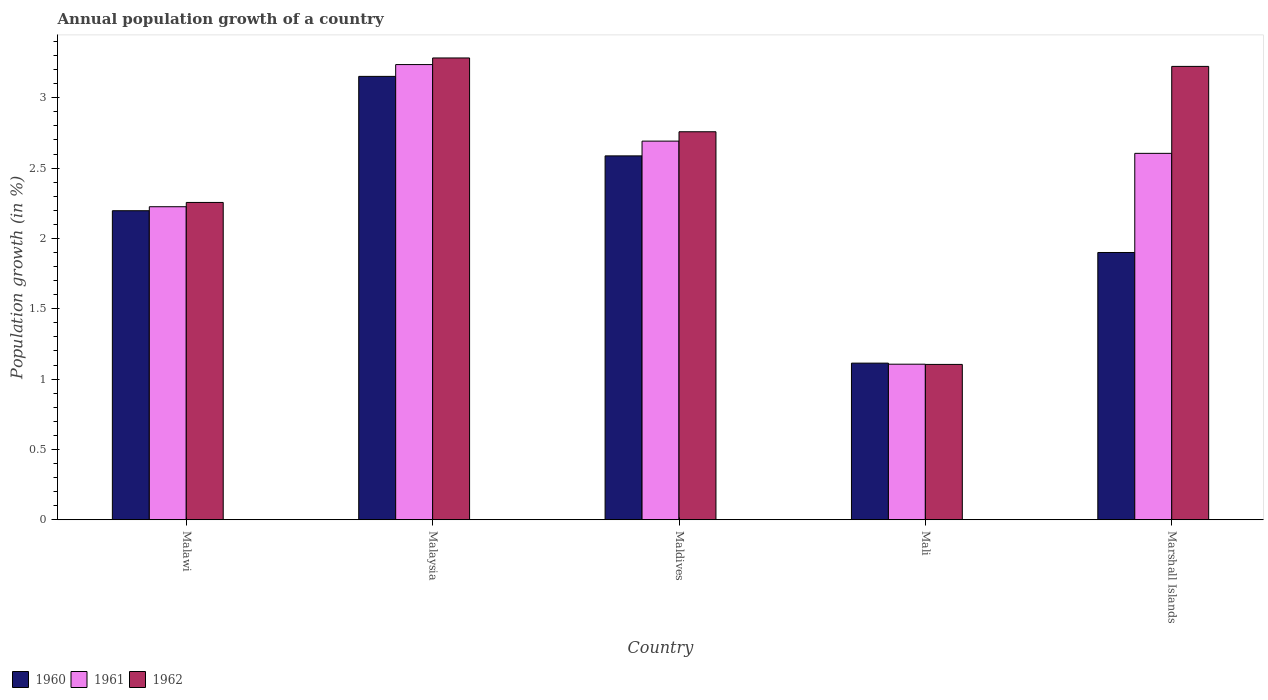How many different coloured bars are there?
Make the answer very short. 3. How many bars are there on the 4th tick from the left?
Make the answer very short. 3. How many bars are there on the 2nd tick from the right?
Offer a very short reply. 3. What is the label of the 1st group of bars from the left?
Your answer should be compact. Malawi. What is the annual population growth in 1961 in Mali?
Provide a short and direct response. 1.11. Across all countries, what is the maximum annual population growth in 1961?
Offer a very short reply. 3.24. Across all countries, what is the minimum annual population growth in 1962?
Provide a short and direct response. 1.1. In which country was the annual population growth in 1961 maximum?
Your answer should be very brief. Malaysia. In which country was the annual population growth in 1962 minimum?
Offer a very short reply. Mali. What is the total annual population growth in 1961 in the graph?
Offer a very short reply. 11.86. What is the difference between the annual population growth in 1960 in Malawi and that in Malaysia?
Your answer should be compact. -0.96. What is the difference between the annual population growth in 1960 in Malaysia and the annual population growth in 1961 in Marshall Islands?
Offer a terse response. 0.55. What is the average annual population growth in 1960 per country?
Offer a terse response. 2.19. What is the difference between the annual population growth of/in 1962 and annual population growth of/in 1960 in Mali?
Your answer should be very brief. -0.01. What is the ratio of the annual population growth in 1960 in Malawi to that in Maldives?
Make the answer very short. 0.85. Is the annual population growth in 1962 in Mali less than that in Marshall Islands?
Keep it short and to the point. Yes. What is the difference between the highest and the second highest annual population growth in 1960?
Provide a succinct answer. -0.57. What is the difference between the highest and the lowest annual population growth in 1961?
Give a very brief answer. 2.13. In how many countries, is the annual population growth in 1962 greater than the average annual population growth in 1962 taken over all countries?
Offer a very short reply. 3. Is the sum of the annual population growth in 1962 in Maldives and Marshall Islands greater than the maximum annual population growth in 1960 across all countries?
Keep it short and to the point. Yes. What does the 3rd bar from the left in Malaysia represents?
Your response must be concise. 1962. How many bars are there?
Ensure brevity in your answer.  15. What is the difference between two consecutive major ticks on the Y-axis?
Give a very brief answer. 0.5. Does the graph contain any zero values?
Make the answer very short. No. Does the graph contain grids?
Keep it short and to the point. No. How are the legend labels stacked?
Give a very brief answer. Horizontal. What is the title of the graph?
Offer a very short reply. Annual population growth of a country. What is the label or title of the X-axis?
Offer a terse response. Country. What is the label or title of the Y-axis?
Make the answer very short. Population growth (in %). What is the Population growth (in %) of 1960 in Malawi?
Offer a terse response. 2.2. What is the Population growth (in %) of 1961 in Malawi?
Your answer should be very brief. 2.23. What is the Population growth (in %) of 1962 in Malawi?
Your answer should be very brief. 2.26. What is the Population growth (in %) of 1960 in Malaysia?
Provide a succinct answer. 3.15. What is the Population growth (in %) in 1961 in Malaysia?
Give a very brief answer. 3.24. What is the Population growth (in %) of 1962 in Malaysia?
Make the answer very short. 3.28. What is the Population growth (in %) in 1960 in Maldives?
Keep it short and to the point. 2.59. What is the Population growth (in %) of 1961 in Maldives?
Your answer should be very brief. 2.69. What is the Population growth (in %) of 1962 in Maldives?
Your answer should be compact. 2.76. What is the Population growth (in %) in 1960 in Mali?
Give a very brief answer. 1.11. What is the Population growth (in %) in 1961 in Mali?
Your answer should be very brief. 1.11. What is the Population growth (in %) of 1962 in Mali?
Provide a short and direct response. 1.1. What is the Population growth (in %) of 1960 in Marshall Islands?
Your response must be concise. 1.9. What is the Population growth (in %) of 1961 in Marshall Islands?
Give a very brief answer. 2.6. What is the Population growth (in %) of 1962 in Marshall Islands?
Make the answer very short. 3.22. Across all countries, what is the maximum Population growth (in %) of 1960?
Your answer should be compact. 3.15. Across all countries, what is the maximum Population growth (in %) in 1961?
Provide a succinct answer. 3.24. Across all countries, what is the maximum Population growth (in %) in 1962?
Give a very brief answer. 3.28. Across all countries, what is the minimum Population growth (in %) of 1960?
Your answer should be very brief. 1.11. Across all countries, what is the minimum Population growth (in %) of 1961?
Provide a short and direct response. 1.11. Across all countries, what is the minimum Population growth (in %) in 1962?
Your response must be concise. 1.1. What is the total Population growth (in %) of 1960 in the graph?
Your answer should be very brief. 10.95. What is the total Population growth (in %) of 1961 in the graph?
Your answer should be very brief. 11.86. What is the total Population growth (in %) of 1962 in the graph?
Provide a succinct answer. 12.62. What is the difference between the Population growth (in %) of 1960 in Malawi and that in Malaysia?
Ensure brevity in your answer.  -0.95. What is the difference between the Population growth (in %) of 1961 in Malawi and that in Malaysia?
Offer a terse response. -1.01. What is the difference between the Population growth (in %) in 1962 in Malawi and that in Malaysia?
Keep it short and to the point. -1.03. What is the difference between the Population growth (in %) of 1960 in Malawi and that in Maldives?
Ensure brevity in your answer.  -0.39. What is the difference between the Population growth (in %) of 1961 in Malawi and that in Maldives?
Your answer should be compact. -0.47. What is the difference between the Population growth (in %) in 1962 in Malawi and that in Maldives?
Offer a terse response. -0.5. What is the difference between the Population growth (in %) of 1960 in Malawi and that in Mali?
Give a very brief answer. 1.08. What is the difference between the Population growth (in %) of 1961 in Malawi and that in Mali?
Your answer should be compact. 1.12. What is the difference between the Population growth (in %) in 1962 in Malawi and that in Mali?
Your answer should be very brief. 1.15. What is the difference between the Population growth (in %) in 1960 in Malawi and that in Marshall Islands?
Ensure brevity in your answer.  0.3. What is the difference between the Population growth (in %) of 1961 in Malawi and that in Marshall Islands?
Your answer should be very brief. -0.38. What is the difference between the Population growth (in %) in 1962 in Malawi and that in Marshall Islands?
Your answer should be compact. -0.97. What is the difference between the Population growth (in %) of 1960 in Malaysia and that in Maldives?
Provide a short and direct response. 0.57. What is the difference between the Population growth (in %) of 1961 in Malaysia and that in Maldives?
Your answer should be very brief. 0.54. What is the difference between the Population growth (in %) in 1962 in Malaysia and that in Maldives?
Offer a terse response. 0.52. What is the difference between the Population growth (in %) of 1960 in Malaysia and that in Mali?
Your answer should be very brief. 2.04. What is the difference between the Population growth (in %) of 1961 in Malaysia and that in Mali?
Offer a very short reply. 2.13. What is the difference between the Population growth (in %) in 1962 in Malaysia and that in Mali?
Provide a short and direct response. 2.18. What is the difference between the Population growth (in %) of 1960 in Malaysia and that in Marshall Islands?
Offer a very short reply. 1.25. What is the difference between the Population growth (in %) of 1961 in Malaysia and that in Marshall Islands?
Ensure brevity in your answer.  0.63. What is the difference between the Population growth (in %) in 1960 in Maldives and that in Mali?
Ensure brevity in your answer.  1.47. What is the difference between the Population growth (in %) in 1961 in Maldives and that in Mali?
Provide a succinct answer. 1.59. What is the difference between the Population growth (in %) of 1962 in Maldives and that in Mali?
Your answer should be very brief. 1.65. What is the difference between the Population growth (in %) of 1960 in Maldives and that in Marshall Islands?
Your response must be concise. 0.69. What is the difference between the Population growth (in %) in 1961 in Maldives and that in Marshall Islands?
Offer a very short reply. 0.09. What is the difference between the Population growth (in %) in 1962 in Maldives and that in Marshall Islands?
Keep it short and to the point. -0.46. What is the difference between the Population growth (in %) in 1960 in Mali and that in Marshall Islands?
Provide a succinct answer. -0.79. What is the difference between the Population growth (in %) of 1961 in Mali and that in Marshall Islands?
Provide a succinct answer. -1.5. What is the difference between the Population growth (in %) of 1962 in Mali and that in Marshall Islands?
Give a very brief answer. -2.12. What is the difference between the Population growth (in %) in 1960 in Malawi and the Population growth (in %) in 1961 in Malaysia?
Your answer should be very brief. -1.04. What is the difference between the Population growth (in %) of 1960 in Malawi and the Population growth (in %) of 1962 in Malaysia?
Provide a short and direct response. -1.09. What is the difference between the Population growth (in %) of 1961 in Malawi and the Population growth (in %) of 1962 in Malaysia?
Ensure brevity in your answer.  -1.06. What is the difference between the Population growth (in %) of 1960 in Malawi and the Population growth (in %) of 1961 in Maldives?
Make the answer very short. -0.49. What is the difference between the Population growth (in %) of 1960 in Malawi and the Population growth (in %) of 1962 in Maldives?
Your answer should be compact. -0.56. What is the difference between the Population growth (in %) of 1961 in Malawi and the Population growth (in %) of 1962 in Maldives?
Your answer should be compact. -0.53. What is the difference between the Population growth (in %) in 1960 in Malawi and the Population growth (in %) in 1961 in Mali?
Make the answer very short. 1.09. What is the difference between the Population growth (in %) in 1960 in Malawi and the Population growth (in %) in 1962 in Mali?
Provide a succinct answer. 1.09. What is the difference between the Population growth (in %) in 1961 in Malawi and the Population growth (in %) in 1962 in Mali?
Your response must be concise. 1.12. What is the difference between the Population growth (in %) of 1960 in Malawi and the Population growth (in %) of 1961 in Marshall Islands?
Provide a short and direct response. -0.41. What is the difference between the Population growth (in %) of 1960 in Malawi and the Population growth (in %) of 1962 in Marshall Islands?
Your response must be concise. -1.03. What is the difference between the Population growth (in %) in 1961 in Malawi and the Population growth (in %) in 1962 in Marshall Islands?
Offer a terse response. -1. What is the difference between the Population growth (in %) in 1960 in Malaysia and the Population growth (in %) in 1961 in Maldives?
Your response must be concise. 0.46. What is the difference between the Population growth (in %) of 1960 in Malaysia and the Population growth (in %) of 1962 in Maldives?
Keep it short and to the point. 0.39. What is the difference between the Population growth (in %) in 1961 in Malaysia and the Population growth (in %) in 1962 in Maldives?
Your response must be concise. 0.48. What is the difference between the Population growth (in %) in 1960 in Malaysia and the Population growth (in %) in 1961 in Mali?
Ensure brevity in your answer.  2.05. What is the difference between the Population growth (in %) of 1960 in Malaysia and the Population growth (in %) of 1962 in Mali?
Offer a very short reply. 2.05. What is the difference between the Population growth (in %) in 1961 in Malaysia and the Population growth (in %) in 1962 in Mali?
Provide a short and direct response. 2.13. What is the difference between the Population growth (in %) of 1960 in Malaysia and the Population growth (in %) of 1961 in Marshall Islands?
Give a very brief answer. 0.55. What is the difference between the Population growth (in %) in 1960 in Malaysia and the Population growth (in %) in 1962 in Marshall Islands?
Your response must be concise. -0.07. What is the difference between the Population growth (in %) in 1961 in Malaysia and the Population growth (in %) in 1962 in Marshall Islands?
Provide a succinct answer. 0.01. What is the difference between the Population growth (in %) of 1960 in Maldives and the Population growth (in %) of 1961 in Mali?
Ensure brevity in your answer.  1.48. What is the difference between the Population growth (in %) in 1960 in Maldives and the Population growth (in %) in 1962 in Mali?
Your answer should be compact. 1.48. What is the difference between the Population growth (in %) in 1961 in Maldives and the Population growth (in %) in 1962 in Mali?
Offer a very short reply. 1.59. What is the difference between the Population growth (in %) of 1960 in Maldives and the Population growth (in %) of 1961 in Marshall Islands?
Provide a short and direct response. -0.02. What is the difference between the Population growth (in %) of 1960 in Maldives and the Population growth (in %) of 1962 in Marshall Islands?
Ensure brevity in your answer.  -0.64. What is the difference between the Population growth (in %) in 1961 in Maldives and the Population growth (in %) in 1962 in Marshall Islands?
Your response must be concise. -0.53. What is the difference between the Population growth (in %) in 1960 in Mali and the Population growth (in %) in 1961 in Marshall Islands?
Offer a terse response. -1.49. What is the difference between the Population growth (in %) of 1960 in Mali and the Population growth (in %) of 1962 in Marshall Islands?
Your answer should be very brief. -2.11. What is the difference between the Population growth (in %) in 1961 in Mali and the Population growth (in %) in 1962 in Marshall Islands?
Your answer should be compact. -2.12. What is the average Population growth (in %) of 1960 per country?
Your answer should be very brief. 2.19. What is the average Population growth (in %) in 1961 per country?
Ensure brevity in your answer.  2.37. What is the average Population growth (in %) in 1962 per country?
Provide a succinct answer. 2.52. What is the difference between the Population growth (in %) of 1960 and Population growth (in %) of 1961 in Malawi?
Ensure brevity in your answer.  -0.03. What is the difference between the Population growth (in %) of 1960 and Population growth (in %) of 1962 in Malawi?
Give a very brief answer. -0.06. What is the difference between the Population growth (in %) of 1961 and Population growth (in %) of 1962 in Malawi?
Provide a short and direct response. -0.03. What is the difference between the Population growth (in %) of 1960 and Population growth (in %) of 1961 in Malaysia?
Your answer should be compact. -0.08. What is the difference between the Population growth (in %) of 1960 and Population growth (in %) of 1962 in Malaysia?
Offer a terse response. -0.13. What is the difference between the Population growth (in %) in 1961 and Population growth (in %) in 1962 in Malaysia?
Provide a short and direct response. -0.05. What is the difference between the Population growth (in %) in 1960 and Population growth (in %) in 1961 in Maldives?
Your response must be concise. -0.1. What is the difference between the Population growth (in %) in 1960 and Population growth (in %) in 1962 in Maldives?
Keep it short and to the point. -0.17. What is the difference between the Population growth (in %) in 1961 and Population growth (in %) in 1962 in Maldives?
Offer a terse response. -0.07. What is the difference between the Population growth (in %) in 1960 and Population growth (in %) in 1961 in Mali?
Your answer should be very brief. 0.01. What is the difference between the Population growth (in %) of 1960 and Population growth (in %) of 1962 in Mali?
Offer a terse response. 0.01. What is the difference between the Population growth (in %) of 1961 and Population growth (in %) of 1962 in Mali?
Your answer should be very brief. 0. What is the difference between the Population growth (in %) in 1960 and Population growth (in %) in 1961 in Marshall Islands?
Make the answer very short. -0.7. What is the difference between the Population growth (in %) in 1960 and Population growth (in %) in 1962 in Marshall Islands?
Offer a terse response. -1.32. What is the difference between the Population growth (in %) in 1961 and Population growth (in %) in 1962 in Marshall Islands?
Your answer should be very brief. -0.62. What is the ratio of the Population growth (in %) in 1960 in Malawi to that in Malaysia?
Provide a short and direct response. 0.7. What is the ratio of the Population growth (in %) in 1961 in Malawi to that in Malaysia?
Your response must be concise. 0.69. What is the ratio of the Population growth (in %) of 1962 in Malawi to that in Malaysia?
Ensure brevity in your answer.  0.69. What is the ratio of the Population growth (in %) of 1960 in Malawi to that in Maldives?
Ensure brevity in your answer.  0.85. What is the ratio of the Population growth (in %) in 1961 in Malawi to that in Maldives?
Ensure brevity in your answer.  0.83. What is the ratio of the Population growth (in %) of 1962 in Malawi to that in Maldives?
Your answer should be compact. 0.82. What is the ratio of the Population growth (in %) in 1960 in Malawi to that in Mali?
Your answer should be compact. 1.97. What is the ratio of the Population growth (in %) in 1961 in Malawi to that in Mali?
Offer a very short reply. 2.01. What is the ratio of the Population growth (in %) of 1962 in Malawi to that in Mali?
Ensure brevity in your answer.  2.04. What is the ratio of the Population growth (in %) in 1960 in Malawi to that in Marshall Islands?
Offer a terse response. 1.16. What is the ratio of the Population growth (in %) of 1961 in Malawi to that in Marshall Islands?
Your response must be concise. 0.85. What is the ratio of the Population growth (in %) of 1962 in Malawi to that in Marshall Islands?
Ensure brevity in your answer.  0.7. What is the ratio of the Population growth (in %) of 1960 in Malaysia to that in Maldives?
Offer a very short reply. 1.22. What is the ratio of the Population growth (in %) in 1961 in Malaysia to that in Maldives?
Provide a short and direct response. 1.2. What is the ratio of the Population growth (in %) of 1962 in Malaysia to that in Maldives?
Your answer should be very brief. 1.19. What is the ratio of the Population growth (in %) in 1960 in Malaysia to that in Mali?
Offer a very short reply. 2.83. What is the ratio of the Population growth (in %) in 1961 in Malaysia to that in Mali?
Make the answer very short. 2.93. What is the ratio of the Population growth (in %) of 1962 in Malaysia to that in Mali?
Your response must be concise. 2.97. What is the ratio of the Population growth (in %) in 1960 in Malaysia to that in Marshall Islands?
Offer a terse response. 1.66. What is the ratio of the Population growth (in %) in 1961 in Malaysia to that in Marshall Islands?
Provide a succinct answer. 1.24. What is the ratio of the Population growth (in %) in 1962 in Malaysia to that in Marshall Islands?
Keep it short and to the point. 1.02. What is the ratio of the Population growth (in %) of 1960 in Maldives to that in Mali?
Keep it short and to the point. 2.32. What is the ratio of the Population growth (in %) of 1961 in Maldives to that in Mali?
Your answer should be very brief. 2.43. What is the ratio of the Population growth (in %) of 1962 in Maldives to that in Mali?
Give a very brief answer. 2.5. What is the ratio of the Population growth (in %) of 1960 in Maldives to that in Marshall Islands?
Offer a very short reply. 1.36. What is the ratio of the Population growth (in %) of 1961 in Maldives to that in Marshall Islands?
Offer a terse response. 1.03. What is the ratio of the Population growth (in %) of 1962 in Maldives to that in Marshall Islands?
Your answer should be very brief. 0.86. What is the ratio of the Population growth (in %) of 1960 in Mali to that in Marshall Islands?
Ensure brevity in your answer.  0.59. What is the ratio of the Population growth (in %) of 1961 in Mali to that in Marshall Islands?
Provide a succinct answer. 0.42. What is the ratio of the Population growth (in %) of 1962 in Mali to that in Marshall Islands?
Ensure brevity in your answer.  0.34. What is the difference between the highest and the second highest Population growth (in %) in 1960?
Offer a terse response. 0.57. What is the difference between the highest and the second highest Population growth (in %) of 1961?
Offer a very short reply. 0.54. What is the difference between the highest and the second highest Population growth (in %) of 1962?
Your response must be concise. 0.06. What is the difference between the highest and the lowest Population growth (in %) in 1960?
Your response must be concise. 2.04. What is the difference between the highest and the lowest Population growth (in %) in 1961?
Your response must be concise. 2.13. What is the difference between the highest and the lowest Population growth (in %) of 1962?
Provide a short and direct response. 2.18. 